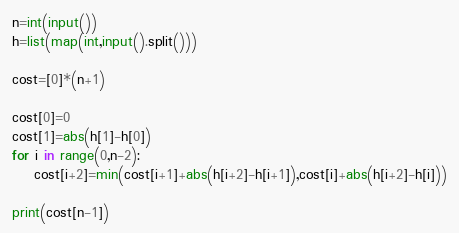<code> <loc_0><loc_0><loc_500><loc_500><_Python_>n=int(input())
h=list(map(int,input().split()))

cost=[0]*(n+1)

cost[0]=0
cost[1]=abs(h[1]-h[0])
for i in range(0,n-2):
    cost[i+2]=min(cost[i+1]+abs(h[i+2]-h[i+1]),cost[i]+abs(h[i+2]-h[i]))

print(cost[n-1])</code> 